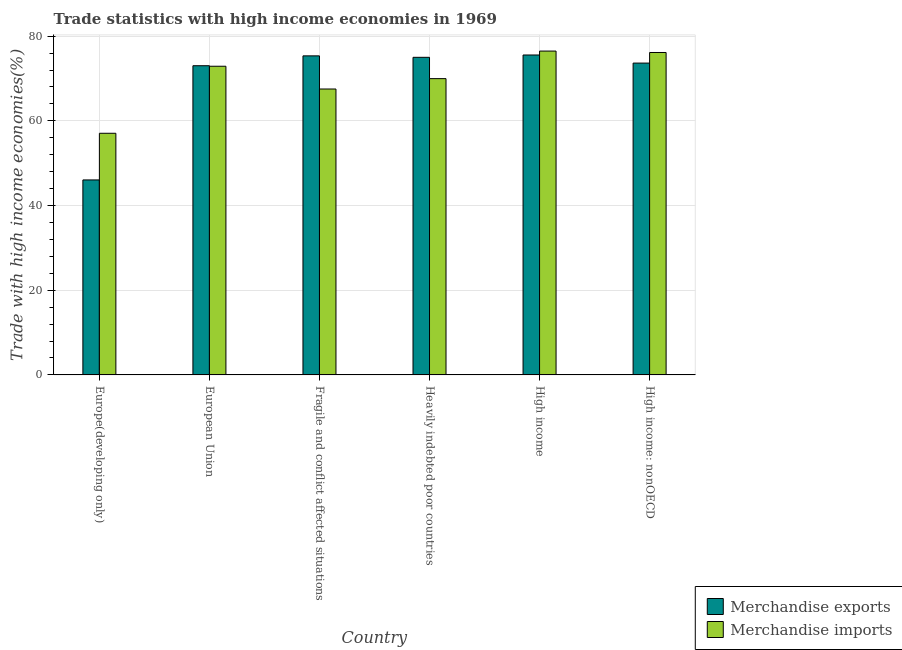Are the number of bars on each tick of the X-axis equal?
Ensure brevity in your answer.  Yes. How many bars are there on the 5th tick from the left?
Offer a terse response. 2. What is the label of the 4th group of bars from the left?
Make the answer very short. Heavily indebted poor countries. In how many cases, is the number of bars for a given country not equal to the number of legend labels?
Offer a very short reply. 0. What is the merchandise imports in High income: nonOECD?
Your answer should be very brief. 76.14. Across all countries, what is the maximum merchandise exports?
Provide a succinct answer. 75.55. Across all countries, what is the minimum merchandise imports?
Offer a terse response. 57.06. In which country was the merchandise imports minimum?
Offer a very short reply. Europe(developing only). What is the total merchandise imports in the graph?
Keep it short and to the point. 420.07. What is the difference between the merchandise exports in European Union and that in High income?
Give a very brief answer. -2.53. What is the difference between the merchandise imports in European Union and the merchandise exports in High income: nonOECD?
Offer a very short reply. -0.74. What is the average merchandise imports per country?
Give a very brief answer. 70.01. What is the difference between the merchandise imports and merchandise exports in High income: nonOECD?
Keep it short and to the point. 2.5. What is the ratio of the merchandise exports in Heavily indebted poor countries to that in High income?
Provide a succinct answer. 0.99. Is the merchandise exports in Heavily indebted poor countries less than that in High income?
Offer a very short reply. Yes. Is the difference between the merchandise exports in European Union and Fragile and conflict affected situations greater than the difference between the merchandise imports in European Union and Fragile and conflict affected situations?
Provide a succinct answer. No. What is the difference between the highest and the second highest merchandise exports?
Ensure brevity in your answer.  0.21. What is the difference between the highest and the lowest merchandise imports?
Offer a very short reply. 19.42. In how many countries, is the merchandise exports greater than the average merchandise exports taken over all countries?
Provide a succinct answer. 5. What does the 1st bar from the left in High income represents?
Give a very brief answer. Merchandise exports. What does the 2nd bar from the right in High income: nonOECD represents?
Keep it short and to the point. Merchandise exports. How many bars are there?
Offer a very short reply. 12. How many countries are there in the graph?
Make the answer very short. 6. What is the difference between two consecutive major ticks on the Y-axis?
Your answer should be very brief. 20. Does the graph contain any zero values?
Provide a succinct answer. No. Where does the legend appear in the graph?
Give a very brief answer. Bottom right. How many legend labels are there?
Your response must be concise. 2. What is the title of the graph?
Provide a succinct answer. Trade statistics with high income economies in 1969. What is the label or title of the Y-axis?
Offer a very short reply. Trade with high income economies(%). What is the Trade with high income economies(%) in Merchandise exports in Europe(developing only)?
Your answer should be compact. 46.05. What is the Trade with high income economies(%) of Merchandise imports in Europe(developing only)?
Provide a succinct answer. 57.06. What is the Trade with high income economies(%) of Merchandise exports in European Union?
Give a very brief answer. 73.02. What is the Trade with high income economies(%) of Merchandise imports in European Union?
Make the answer very short. 72.9. What is the Trade with high income economies(%) of Merchandise exports in Fragile and conflict affected situations?
Make the answer very short. 75.35. What is the Trade with high income economies(%) in Merchandise imports in Fragile and conflict affected situations?
Your answer should be very brief. 67.52. What is the Trade with high income economies(%) of Merchandise exports in Heavily indebted poor countries?
Give a very brief answer. 75. What is the Trade with high income economies(%) of Merchandise imports in Heavily indebted poor countries?
Give a very brief answer. 69.97. What is the Trade with high income economies(%) of Merchandise exports in High income?
Offer a terse response. 75.55. What is the Trade with high income economies(%) of Merchandise imports in High income?
Your answer should be compact. 76.48. What is the Trade with high income economies(%) of Merchandise exports in High income: nonOECD?
Give a very brief answer. 73.64. What is the Trade with high income economies(%) of Merchandise imports in High income: nonOECD?
Offer a very short reply. 76.14. Across all countries, what is the maximum Trade with high income economies(%) in Merchandise exports?
Your answer should be compact. 75.55. Across all countries, what is the maximum Trade with high income economies(%) of Merchandise imports?
Make the answer very short. 76.48. Across all countries, what is the minimum Trade with high income economies(%) of Merchandise exports?
Provide a short and direct response. 46.05. Across all countries, what is the minimum Trade with high income economies(%) in Merchandise imports?
Offer a terse response. 57.06. What is the total Trade with high income economies(%) of Merchandise exports in the graph?
Make the answer very short. 418.61. What is the total Trade with high income economies(%) of Merchandise imports in the graph?
Your response must be concise. 420.07. What is the difference between the Trade with high income economies(%) in Merchandise exports in Europe(developing only) and that in European Union?
Keep it short and to the point. -26.97. What is the difference between the Trade with high income economies(%) in Merchandise imports in Europe(developing only) and that in European Union?
Offer a very short reply. -15.83. What is the difference between the Trade with high income economies(%) in Merchandise exports in Europe(developing only) and that in Fragile and conflict affected situations?
Offer a terse response. -29.3. What is the difference between the Trade with high income economies(%) of Merchandise imports in Europe(developing only) and that in Fragile and conflict affected situations?
Provide a short and direct response. -10.45. What is the difference between the Trade with high income economies(%) of Merchandise exports in Europe(developing only) and that in Heavily indebted poor countries?
Offer a very short reply. -28.96. What is the difference between the Trade with high income economies(%) of Merchandise imports in Europe(developing only) and that in Heavily indebted poor countries?
Ensure brevity in your answer.  -12.91. What is the difference between the Trade with high income economies(%) in Merchandise exports in Europe(developing only) and that in High income?
Your answer should be very brief. -29.51. What is the difference between the Trade with high income economies(%) in Merchandise imports in Europe(developing only) and that in High income?
Your answer should be compact. -19.42. What is the difference between the Trade with high income economies(%) of Merchandise exports in Europe(developing only) and that in High income: nonOECD?
Give a very brief answer. -27.6. What is the difference between the Trade with high income economies(%) of Merchandise imports in Europe(developing only) and that in High income: nonOECD?
Give a very brief answer. -19.08. What is the difference between the Trade with high income economies(%) in Merchandise exports in European Union and that in Fragile and conflict affected situations?
Your answer should be very brief. -2.33. What is the difference between the Trade with high income economies(%) in Merchandise imports in European Union and that in Fragile and conflict affected situations?
Provide a short and direct response. 5.38. What is the difference between the Trade with high income economies(%) of Merchandise exports in European Union and that in Heavily indebted poor countries?
Provide a succinct answer. -1.99. What is the difference between the Trade with high income economies(%) in Merchandise imports in European Union and that in Heavily indebted poor countries?
Your answer should be compact. 2.93. What is the difference between the Trade with high income economies(%) of Merchandise exports in European Union and that in High income?
Your response must be concise. -2.53. What is the difference between the Trade with high income economies(%) in Merchandise imports in European Union and that in High income?
Offer a very short reply. -3.58. What is the difference between the Trade with high income economies(%) in Merchandise exports in European Union and that in High income: nonOECD?
Provide a short and direct response. -0.62. What is the difference between the Trade with high income economies(%) in Merchandise imports in European Union and that in High income: nonOECD?
Your response must be concise. -3.24. What is the difference between the Trade with high income economies(%) of Merchandise exports in Fragile and conflict affected situations and that in Heavily indebted poor countries?
Your answer should be very brief. 0.34. What is the difference between the Trade with high income economies(%) in Merchandise imports in Fragile and conflict affected situations and that in Heavily indebted poor countries?
Give a very brief answer. -2.45. What is the difference between the Trade with high income economies(%) of Merchandise exports in Fragile and conflict affected situations and that in High income?
Your answer should be very brief. -0.21. What is the difference between the Trade with high income economies(%) in Merchandise imports in Fragile and conflict affected situations and that in High income?
Your answer should be very brief. -8.96. What is the difference between the Trade with high income economies(%) of Merchandise exports in Fragile and conflict affected situations and that in High income: nonOECD?
Provide a short and direct response. 1.71. What is the difference between the Trade with high income economies(%) of Merchandise imports in Fragile and conflict affected situations and that in High income: nonOECD?
Offer a terse response. -8.62. What is the difference between the Trade with high income economies(%) in Merchandise exports in Heavily indebted poor countries and that in High income?
Keep it short and to the point. -0.55. What is the difference between the Trade with high income economies(%) of Merchandise imports in Heavily indebted poor countries and that in High income?
Offer a terse response. -6.51. What is the difference between the Trade with high income economies(%) in Merchandise exports in Heavily indebted poor countries and that in High income: nonOECD?
Your response must be concise. 1.36. What is the difference between the Trade with high income economies(%) in Merchandise imports in Heavily indebted poor countries and that in High income: nonOECD?
Keep it short and to the point. -6.17. What is the difference between the Trade with high income economies(%) of Merchandise exports in High income and that in High income: nonOECD?
Your answer should be very brief. 1.91. What is the difference between the Trade with high income economies(%) in Merchandise imports in High income and that in High income: nonOECD?
Give a very brief answer. 0.34. What is the difference between the Trade with high income economies(%) of Merchandise exports in Europe(developing only) and the Trade with high income economies(%) of Merchandise imports in European Union?
Give a very brief answer. -26.85. What is the difference between the Trade with high income economies(%) of Merchandise exports in Europe(developing only) and the Trade with high income economies(%) of Merchandise imports in Fragile and conflict affected situations?
Your answer should be very brief. -21.47. What is the difference between the Trade with high income economies(%) of Merchandise exports in Europe(developing only) and the Trade with high income economies(%) of Merchandise imports in Heavily indebted poor countries?
Your response must be concise. -23.93. What is the difference between the Trade with high income economies(%) in Merchandise exports in Europe(developing only) and the Trade with high income economies(%) in Merchandise imports in High income?
Ensure brevity in your answer.  -30.43. What is the difference between the Trade with high income economies(%) of Merchandise exports in Europe(developing only) and the Trade with high income economies(%) of Merchandise imports in High income: nonOECD?
Offer a very short reply. -30.1. What is the difference between the Trade with high income economies(%) of Merchandise exports in European Union and the Trade with high income economies(%) of Merchandise imports in Fragile and conflict affected situations?
Your response must be concise. 5.5. What is the difference between the Trade with high income economies(%) in Merchandise exports in European Union and the Trade with high income economies(%) in Merchandise imports in Heavily indebted poor countries?
Make the answer very short. 3.05. What is the difference between the Trade with high income economies(%) of Merchandise exports in European Union and the Trade with high income economies(%) of Merchandise imports in High income?
Provide a succinct answer. -3.46. What is the difference between the Trade with high income economies(%) of Merchandise exports in European Union and the Trade with high income economies(%) of Merchandise imports in High income: nonOECD?
Provide a short and direct response. -3.12. What is the difference between the Trade with high income economies(%) of Merchandise exports in Fragile and conflict affected situations and the Trade with high income economies(%) of Merchandise imports in Heavily indebted poor countries?
Your answer should be very brief. 5.38. What is the difference between the Trade with high income economies(%) in Merchandise exports in Fragile and conflict affected situations and the Trade with high income economies(%) in Merchandise imports in High income?
Your response must be concise. -1.13. What is the difference between the Trade with high income economies(%) of Merchandise exports in Fragile and conflict affected situations and the Trade with high income economies(%) of Merchandise imports in High income: nonOECD?
Your answer should be compact. -0.79. What is the difference between the Trade with high income economies(%) in Merchandise exports in Heavily indebted poor countries and the Trade with high income economies(%) in Merchandise imports in High income?
Offer a terse response. -1.48. What is the difference between the Trade with high income economies(%) in Merchandise exports in Heavily indebted poor countries and the Trade with high income economies(%) in Merchandise imports in High income: nonOECD?
Provide a short and direct response. -1.14. What is the difference between the Trade with high income economies(%) in Merchandise exports in High income and the Trade with high income economies(%) in Merchandise imports in High income: nonOECD?
Your answer should be compact. -0.59. What is the average Trade with high income economies(%) of Merchandise exports per country?
Provide a succinct answer. 69.77. What is the average Trade with high income economies(%) in Merchandise imports per country?
Make the answer very short. 70.01. What is the difference between the Trade with high income economies(%) of Merchandise exports and Trade with high income economies(%) of Merchandise imports in Europe(developing only)?
Give a very brief answer. -11.02. What is the difference between the Trade with high income economies(%) in Merchandise exports and Trade with high income economies(%) in Merchandise imports in European Union?
Provide a succinct answer. 0.12. What is the difference between the Trade with high income economies(%) in Merchandise exports and Trade with high income economies(%) in Merchandise imports in Fragile and conflict affected situations?
Make the answer very short. 7.83. What is the difference between the Trade with high income economies(%) of Merchandise exports and Trade with high income economies(%) of Merchandise imports in Heavily indebted poor countries?
Make the answer very short. 5.03. What is the difference between the Trade with high income economies(%) of Merchandise exports and Trade with high income economies(%) of Merchandise imports in High income?
Provide a succinct answer. -0.93. What is the difference between the Trade with high income economies(%) in Merchandise exports and Trade with high income economies(%) in Merchandise imports in High income: nonOECD?
Provide a succinct answer. -2.5. What is the ratio of the Trade with high income economies(%) of Merchandise exports in Europe(developing only) to that in European Union?
Your answer should be compact. 0.63. What is the ratio of the Trade with high income economies(%) of Merchandise imports in Europe(developing only) to that in European Union?
Your answer should be compact. 0.78. What is the ratio of the Trade with high income economies(%) in Merchandise exports in Europe(developing only) to that in Fragile and conflict affected situations?
Offer a very short reply. 0.61. What is the ratio of the Trade with high income economies(%) in Merchandise imports in Europe(developing only) to that in Fragile and conflict affected situations?
Keep it short and to the point. 0.85. What is the ratio of the Trade with high income economies(%) in Merchandise exports in Europe(developing only) to that in Heavily indebted poor countries?
Provide a succinct answer. 0.61. What is the ratio of the Trade with high income economies(%) of Merchandise imports in Europe(developing only) to that in Heavily indebted poor countries?
Your answer should be compact. 0.82. What is the ratio of the Trade with high income economies(%) of Merchandise exports in Europe(developing only) to that in High income?
Give a very brief answer. 0.61. What is the ratio of the Trade with high income economies(%) in Merchandise imports in Europe(developing only) to that in High income?
Your answer should be very brief. 0.75. What is the ratio of the Trade with high income economies(%) of Merchandise exports in Europe(developing only) to that in High income: nonOECD?
Your answer should be compact. 0.63. What is the ratio of the Trade with high income economies(%) in Merchandise imports in Europe(developing only) to that in High income: nonOECD?
Make the answer very short. 0.75. What is the ratio of the Trade with high income economies(%) of Merchandise exports in European Union to that in Fragile and conflict affected situations?
Give a very brief answer. 0.97. What is the ratio of the Trade with high income economies(%) of Merchandise imports in European Union to that in Fragile and conflict affected situations?
Give a very brief answer. 1.08. What is the ratio of the Trade with high income economies(%) in Merchandise exports in European Union to that in Heavily indebted poor countries?
Ensure brevity in your answer.  0.97. What is the ratio of the Trade with high income economies(%) of Merchandise imports in European Union to that in Heavily indebted poor countries?
Ensure brevity in your answer.  1.04. What is the ratio of the Trade with high income economies(%) in Merchandise exports in European Union to that in High income?
Keep it short and to the point. 0.97. What is the ratio of the Trade with high income economies(%) in Merchandise imports in European Union to that in High income?
Provide a short and direct response. 0.95. What is the ratio of the Trade with high income economies(%) in Merchandise imports in European Union to that in High income: nonOECD?
Provide a succinct answer. 0.96. What is the ratio of the Trade with high income economies(%) in Merchandise exports in Fragile and conflict affected situations to that in Heavily indebted poor countries?
Provide a succinct answer. 1. What is the ratio of the Trade with high income economies(%) of Merchandise imports in Fragile and conflict affected situations to that in Heavily indebted poor countries?
Offer a terse response. 0.96. What is the ratio of the Trade with high income economies(%) in Merchandise imports in Fragile and conflict affected situations to that in High income?
Provide a short and direct response. 0.88. What is the ratio of the Trade with high income economies(%) of Merchandise exports in Fragile and conflict affected situations to that in High income: nonOECD?
Offer a very short reply. 1.02. What is the ratio of the Trade with high income economies(%) in Merchandise imports in Fragile and conflict affected situations to that in High income: nonOECD?
Offer a terse response. 0.89. What is the ratio of the Trade with high income economies(%) in Merchandise imports in Heavily indebted poor countries to that in High income?
Your response must be concise. 0.91. What is the ratio of the Trade with high income economies(%) of Merchandise exports in Heavily indebted poor countries to that in High income: nonOECD?
Give a very brief answer. 1.02. What is the ratio of the Trade with high income economies(%) in Merchandise imports in Heavily indebted poor countries to that in High income: nonOECD?
Give a very brief answer. 0.92. What is the difference between the highest and the second highest Trade with high income economies(%) in Merchandise exports?
Provide a succinct answer. 0.21. What is the difference between the highest and the second highest Trade with high income economies(%) of Merchandise imports?
Your answer should be compact. 0.34. What is the difference between the highest and the lowest Trade with high income economies(%) of Merchandise exports?
Make the answer very short. 29.51. What is the difference between the highest and the lowest Trade with high income economies(%) of Merchandise imports?
Offer a very short reply. 19.42. 